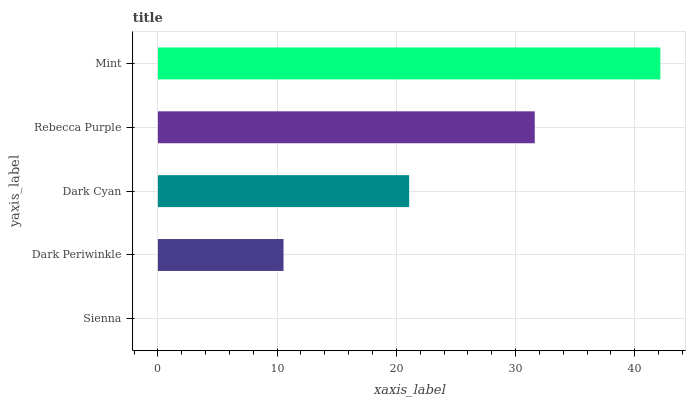Is Sienna the minimum?
Answer yes or no. Yes. Is Mint the maximum?
Answer yes or no. Yes. Is Dark Periwinkle the minimum?
Answer yes or no. No. Is Dark Periwinkle the maximum?
Answer yes or no. No. Is Dark Periwinkle greater than Sienna?
Answer yes or no. Yes. Is Sienna less than Dark Periwinkle?
Answer yes or no. Yes. Is Sienna greater than Dark Periwinkle?
Answer yes or no. No. Is Dark Periwinkle less than Sienna?
Answer yes or no. No. Is Dark Cyan the high median?
Answer yes or no. Yes. Is Dark Cyan the low median?
Answer yes or no. Yes. Is Rebecca Purple the high median?
Answer yes or no. No. Is Rebecca Purple the low median?
Answer yes or no. No. 